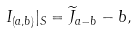<formula> <loc_0><loc_0><loc_500><loc_500>I _ { ( a , b ) } | _ { S } = \widetilde { J } _ { a - b } - b ,</formula> 